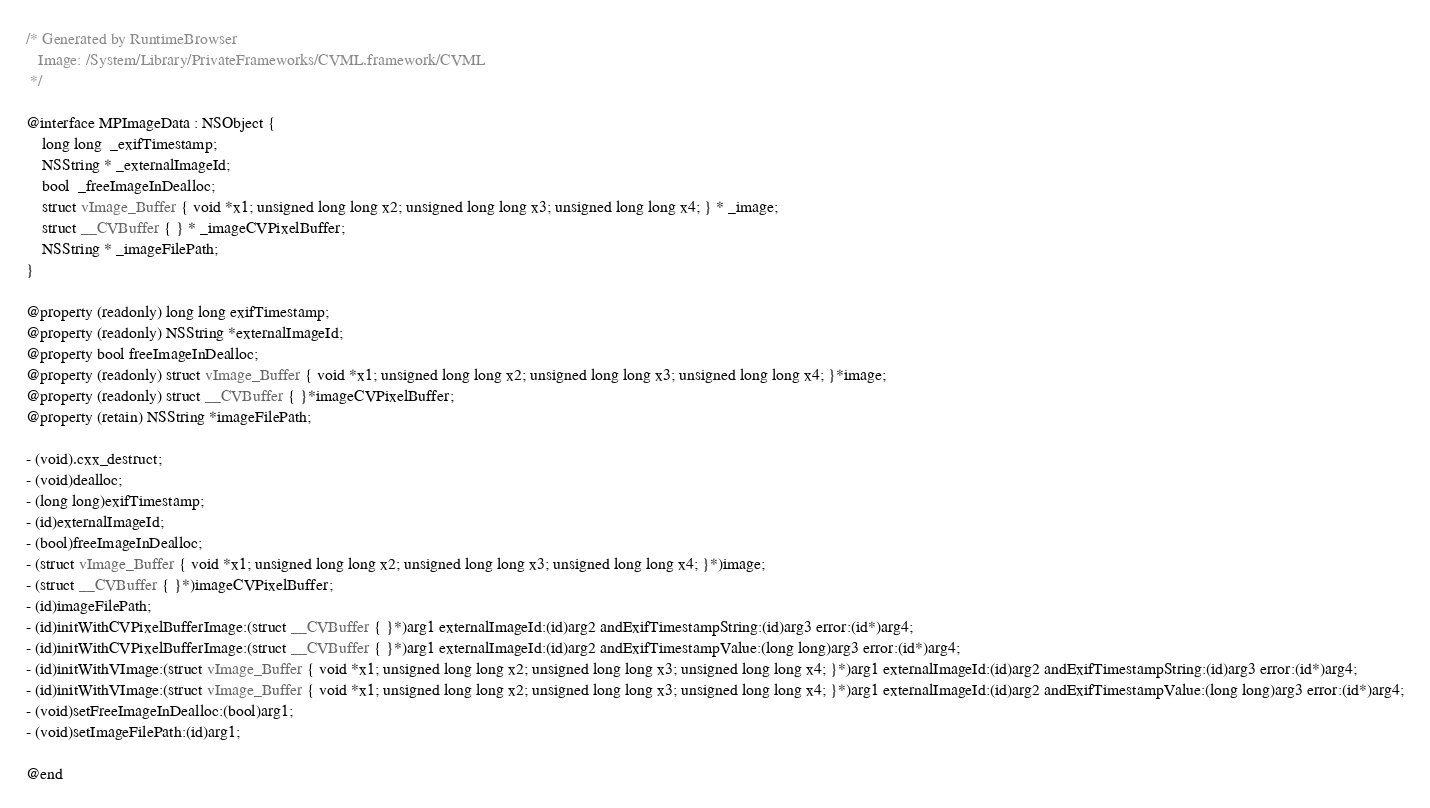Convert code to text. <code><loc_0><loc_0><loc_500><loc_500><_C_>/* Generated by RuntimeBrowser
   Image: /System/Library/PrivateFrameworks/CVML.framework/CVML
 */

@interface MPImageData : NSObject {
    long long  _exifTimestamp;
    NSString * _externalImageId;
    bool  _freeImageInDealloc;
    struct vImage_Buffer { void *x1; unsigned long long x2; unsigned long long x3; unsigned long long x4; } * _image;
    struct __CVBuffer { } * _imageCVPixelBuffer;
    NSString * _imageFilePath;
}

@property (readonly) long long exifTimestamp;
@property (readonly) NSString *externalImageId;
@property bool freeImageInDealloc;
@property (readonly) struct vImage_Buffer { void *x1; unsigned long long x2; unsigned long long x3; unsigned long long x4; }*image;
@property (readonly) struct __CVBuffer { }*imageCVPixelBuffer;
@property (retain) NSString *imageFilePath;

- (void).cxx_destruct;
- (void)dealloc;
- (long long)exifTimestamp;
- (id)externalImageId;
- (bool)freeImageInDealloc;
- (struct vImage_Buffer { void *x1; unsigned long long x2; unsigned long long x3; unsigned long long x4; }*)image;
- (struct __CVBuffer { }*)imageCVPixelBuffer;
- (id)imageFilePath;
- (id)initWithCVPixelBufferImage:(struct __CVBuffer { }*)arg1 externalImageId:(id)arg2 andExifTimestampString:(id)arg3 error:(id*)arg4;
- (id)initWithCVPixelBufferImage:(struct __CVBuffer { }*)arg1 externalImageId:(id)arg2 andExifTimestampValue:(long long)arg3 error:(id*)arg4;
- (id)initWithVImage:(struct vImage_Buffer { void *x1; unsigned long long x2; unsigned long long x3; unsigned long long x4; }*)arg1 externalImageId:(id)arg2 andExifTimestampString:(id)arg3 error:(id*)arg4;
- (id)initWithVImage:(struct vImage_Buffer { void *x1; unsigned long long x2; unsigned long long x3; unsigned long long x4; }*)arg1 externalImageId:(id)arg2 andExifTimestampValue:(long long)arg3 error:(id*)arg4;
- (void)setFreeImageInDealloc:(bool)arg1;
- (void)setImageFilePath:(id)arg1;

@end
</code> 